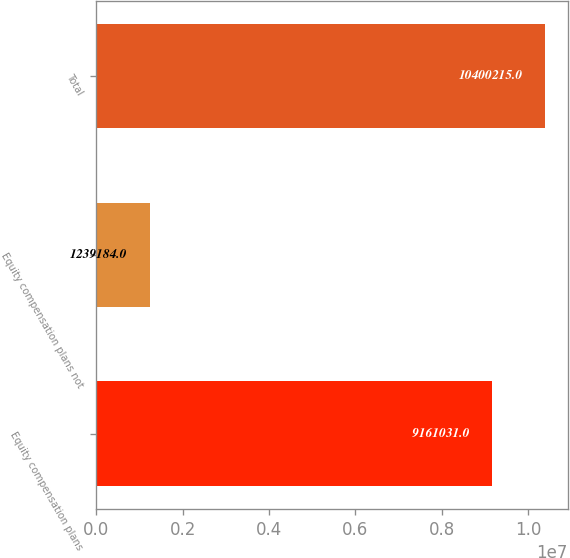<chart> <loc_0><loc_0><loc_500><loc_500><bar_chart><fcel>Equity compensation plans<fcel>Equity compensation plans not<fcel>Total<nl><fcel>9.16103e+06<fcel>1.23918e+06<fcel>1.04002e+07<nl></chart> 